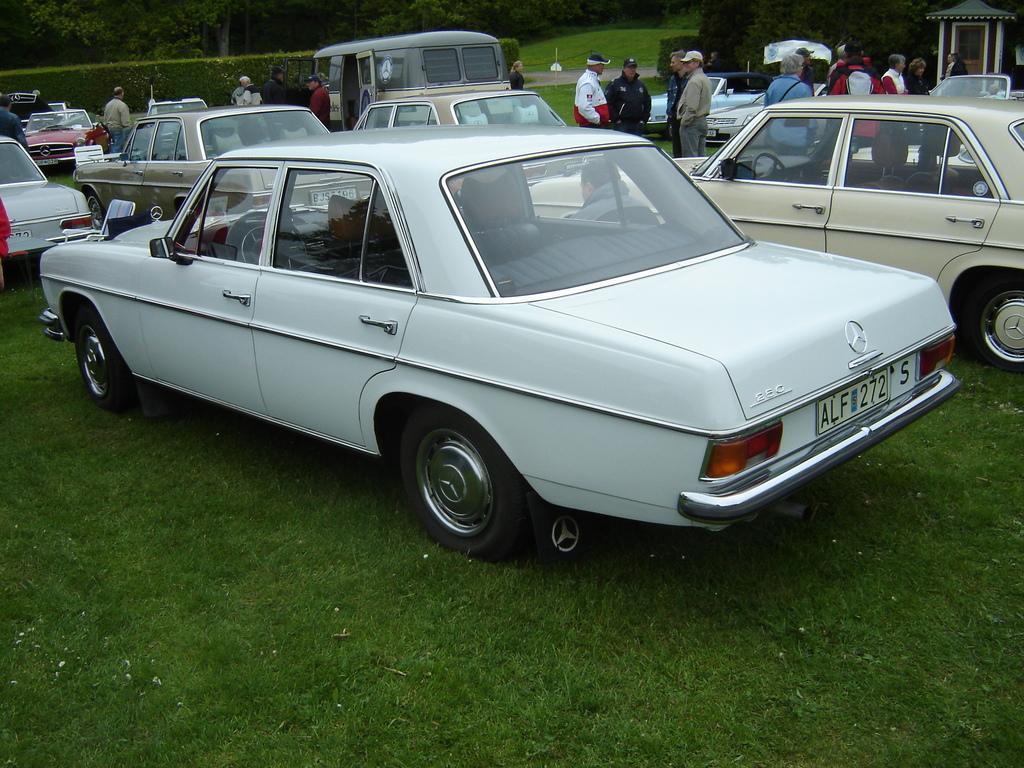How would you summarize this image in a sentence or two? In this picture I can see vehicles and people standing on the ground. In the background I can see trees and grass. On the right side I can see something. 